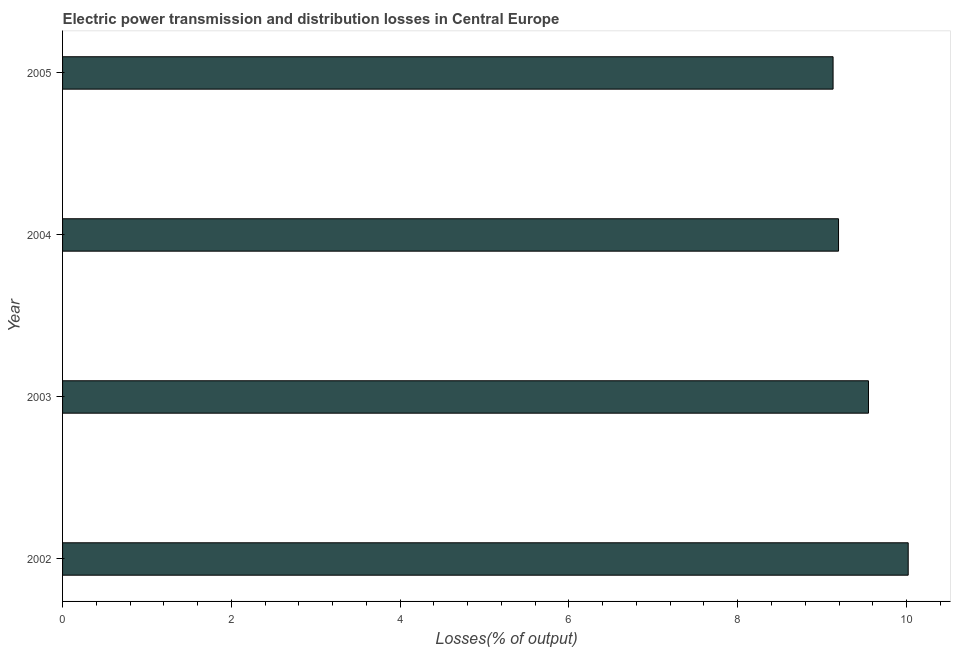Does the graph contain any zero values?
Your answer should be compact. No. Does the graph contain grids?
Give a very brief answer. No. What is the title of the graph?
Offer a very short reply. Electric power transmission and distribution losses in Central Europe. What is the label or title of the X-axis?
Provide a succinct answer. Losses(% of output). What is the electric power transmission and distribution losses in 2004?
Give a very brief answer. 9.19. Across all years, what is the maximum electric power transmission and distribution losses?
Your answer should be compact. 10.02. Across all years, what is the minimum electric power transmission and distribution losses?
Offer a very short reply. 9.13. What is the sum of the electric power transmission and distribution losses?
Give a very brief answer. 37.89. What is the difference between the electric power transmission and distribution losses in 2003 and 2005?
Keep it short and to the point. 0.42. What is the average electric power transmission and distribution losses per year?
Keep it short and to the point. 9.47. What is the median electric power transmission and distribution losses?
Make the answer very short. 9.37. In how many years, is the electric power transmission and distribution losses greater than 8 %?
Offer a terse response. 4. What is the difference between the highest and the second highest electric power transmission and distribution losses?
Your answer should be compact. 0.47. What is the difference between the highest and the lowest electric power transmission and distribution losses?
Your response must be concise. 0.89. In how many years, is the electric power transmission and distribution losses greater than the average electric power transmission and distribution losses taken over all years?
Give a very brief answer. 2. How many bars are there?
Your answer should be compact. 4. How many years are there in the graph?
Give a very brief answer. 4. What is the difference between two consecutive major ticks on the X-axis?
Your response must be concise. 2. What is the Losses(% of output) of 2002?
Your answer should be very brief. 10.02. What is the Losses(% of output) of 2003?
Your answer should be very brief. 9.55. What is the Losses(% of output) in 2004?
Offer a very short reply. 9.19. What is the Losses(% of output) of 2005?
Keep it short and to the point. 9.13. What is the difference between the Losses(% of output) in 2002 and 2003?
Offer a terse response. 0.47. What is the difference between the Losses(% of output) in 2002 and 2004?
Offer a very short reply. 0.83. What is the difference between the Losses(% of output) in 2002 and 2005?
Your response must be concise. 0.89. What is the difference between the Losses(% of output) in 2003 and 2004?
Give a very brief answer. 0.36. What is the difference between the Losses(% of output) in 2003 and 2005?
Provide a short and direct response. 0.42. What is the difference between the Losses(% of output) in 2004 and 2005?
Give a very brief answer. 0.06. What is the ratio of the Losses(% of output) in 2002 to that in 2003?
Make the answer very short. 1.05. What is the ratio of the Losses(% of output) in 2002 to that in 2004?
Your answer should be very brief. 1.09. What is the ratio of the Losses(% of output) in 2002 to that in 2005?
Your answer should be very brief. 1.1. What is the ratio of the Losses(% of output) in 2003 to that in 2004?
Offer a terse response. 1.04. What is the ratio of the Losses(% of output) in 2003 to that in 2005?
Give a very brief answer. 1.05. What is the ratio of the Losses(% of output) in 2004 to that in 2005?
Provide a short and direct response. 1.01. 